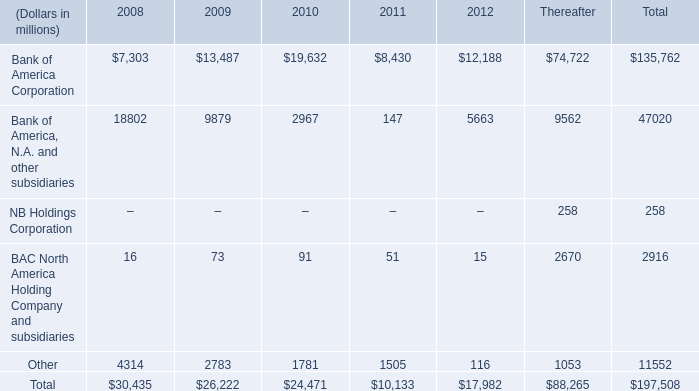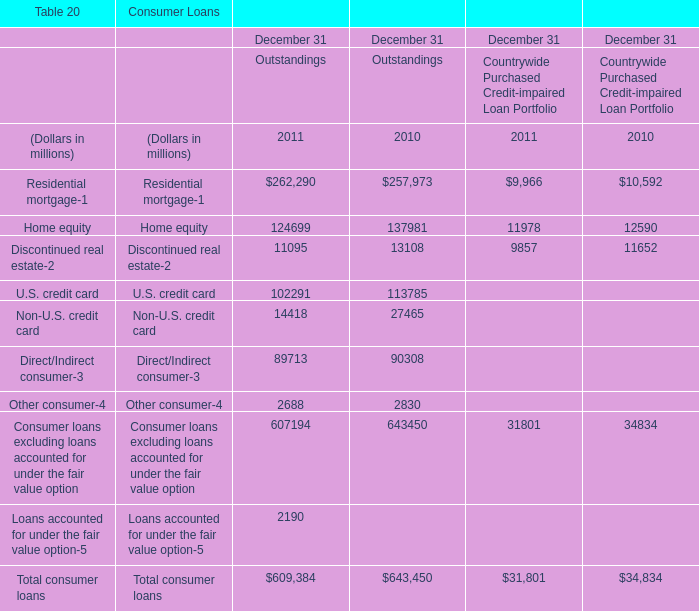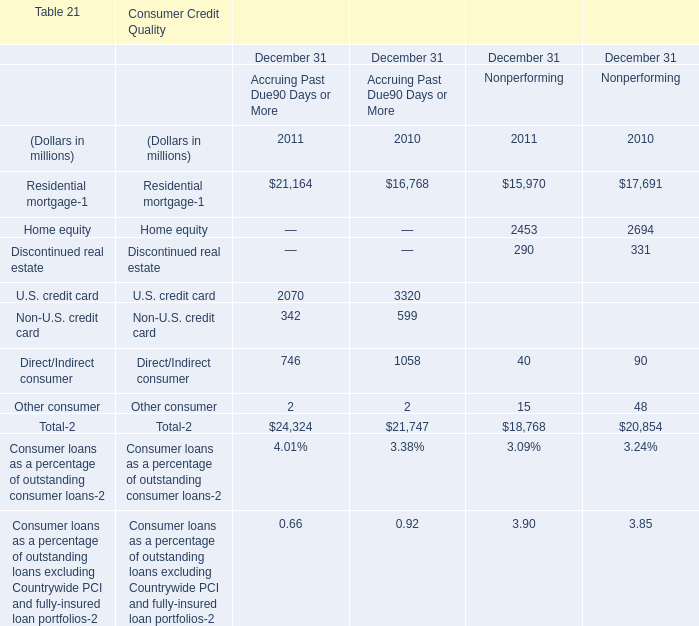What is the total amount of Bank of America Corporation of 2011, and Home equity of Consumer Credit Quality December 31 Nonperforming 2010 ? 
Computations: (8430.0 + 2694.0)
Answer: 11124.0. 